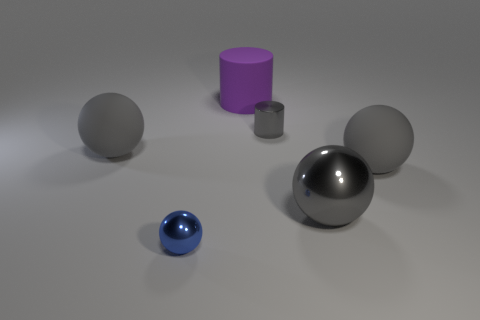Subtract all red blocks. How many gray spheres are left? 3 Add 2 large rubber objects. How many objects exist? 8 Subtract all cylinders. How many objects are left? 4 Subtract 0 green blocks. How many objects are left? 6 Subtract all small blue spheres. Subtract all big cylinders. How many objects are left? 4 Add 2 purple matte cylinders. How many purple matte cylinders are left? 3 Add 5 tiny purple rubber cylinders. How many tiny purple rubber cylinders exist? 5 